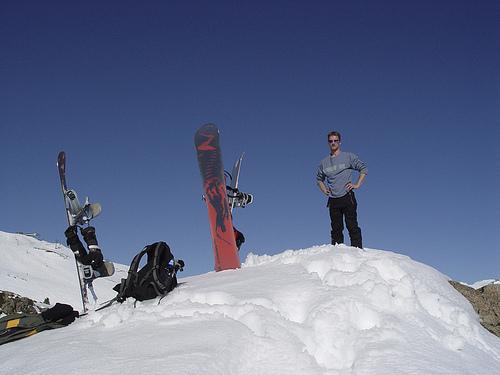Where is this man standing?
Quick response, please. Top of hill. What is standing next to the man?
Keep it brief. Snowboard. What color is the snowboard?
Be succinct. Red and black. 